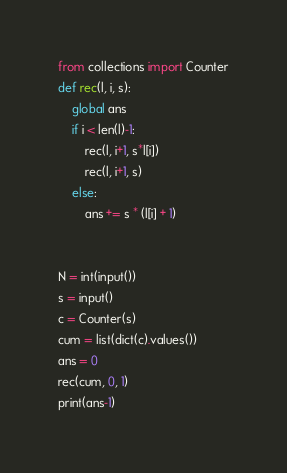<code> <loc_0><loc_0><loc_500><loc_500><_Python_>from collections import Counter
def rec(l, i, s):
    global ans
    if i < len(l)-1:
        rec(l, i+1, s*l[i])
        rec(l, i+1, s)
    else:
        ans += s * (l[i] + 1)


N = int(input())
s = input()
c = Counter(s)
cum = list(dict(c).values())
ans = 0
rec(cum, 0, 1)
print(ans-1)
</code> 